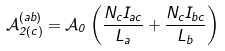Convert formula to latex. <formula><loc_0><loc_0><loc_500><loc_500>\mathcal { A } _ { 2 ( c ) } ^ { ( a b ) } = \mathcal { A } _ { 0 } \left ( \frac { N _ { c } I _ { a c } } { L _ { a } } + \frac { N _ { c } I _ { b c } } { L _ { b } } \right )</formula> 